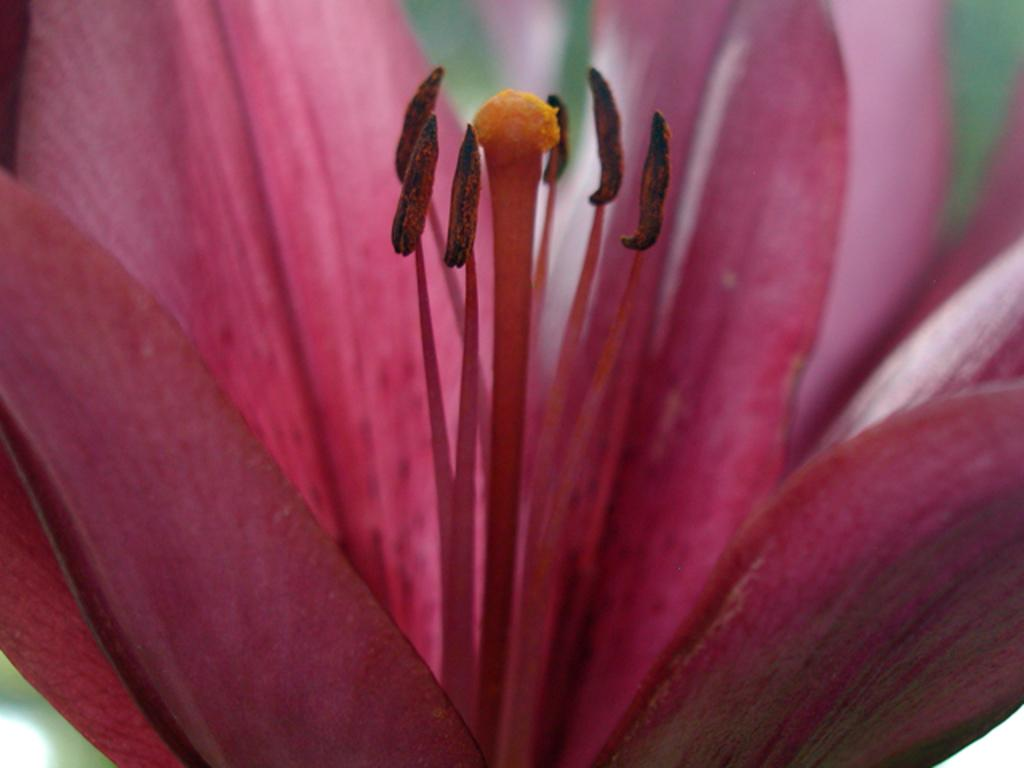What is the main subject of the picture? There is a flower in the picture. Can you describe the background of the image? The background of the image is blurred. How many frogs can be seen hopping on the trail in the image? There are no frogs or trails present in the image; it features a flower with a blurred background. 